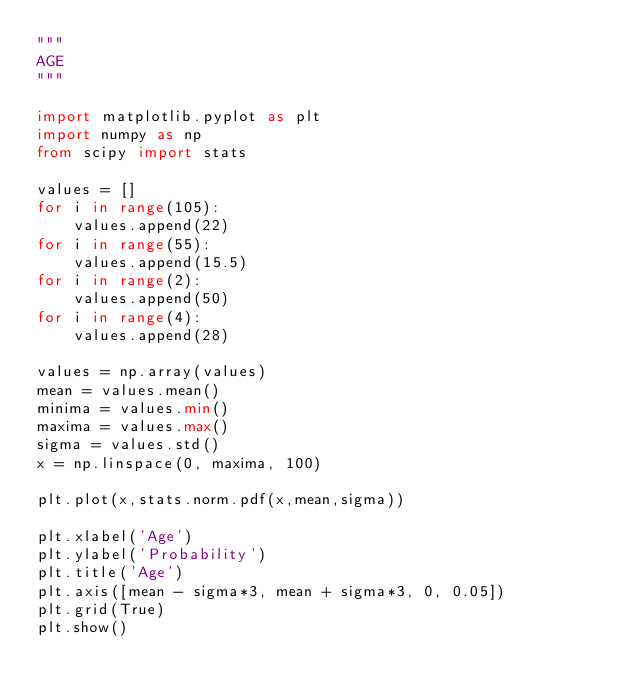<code> <loc_0><loc_0><loc_500><loc_500><_Python_>"""
AGE
"""

import matplotlib.pyplot as plt
import numpy as np
from scipy import stats

values = []
for i in range(105):
    values.append(22)
for i in range(55):
    values.append(15.5)
for i in range(2):
    values.append(50)
for i in range(4):
    values.append(28)

values = np.array(values)
mean = values.mean()
minima = values.min()
maxima = values.max()
sigma = values.std()
x = np.linspace(0, maxima, 100)

plt.plot(x,stats.norm.pdf(x,mean,sigma))

plt.xlabel('Age')
plt.ylabel('Probability')
plt.title('Age')
plt.axis([mean - sigma*3, mean + sigma*3, 0, 0.05])
plt.grid(True)
plt.show()</code> 